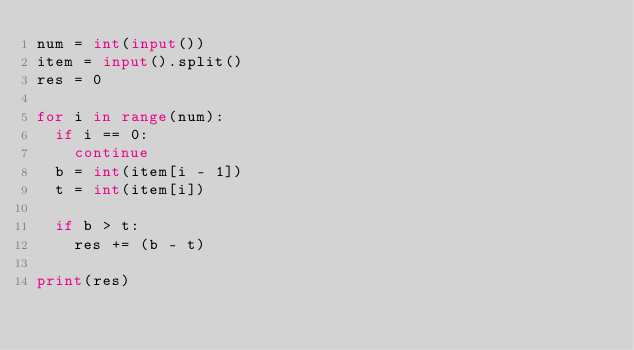<code> <loc_0><loc_0><loc_500><loc_500><_Python_>num = int(input())
item = input().split()
res = 0

for i in range(num):
  if i == 0:
    continue
  b = int(item[i - 1])
  t = int(item[i])
  
  if b > t:
    res += (b - t)
      
print(res)</code> 